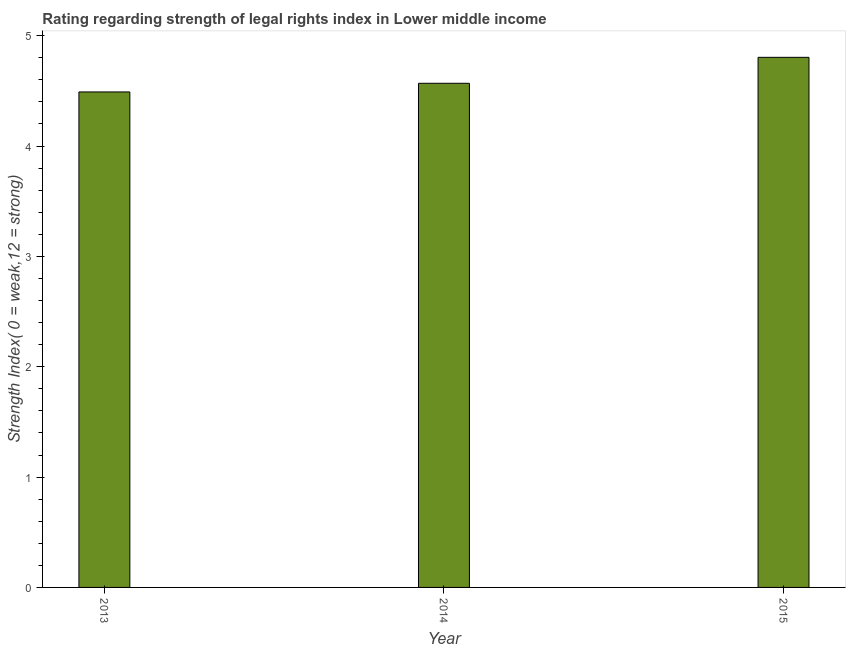Does the graph contain grids?
Make the answer very short. No. What is the title of the graph?
Offer a terse response. Rating regarding strength of legal rights index in Lower middle income. What is the label or title of the X-axis?
Offer a very short reply. Year. What is the label or title of the Y-axis?
Keep it short and to the point. Strength Index( 0 = weak,12 = strong). What is the strength of legal rights index in 2015?
Make the answer very short. 4.8. Across all years, what is the maximum strength of legal rights index?
Keep it short and to the point. 4.8. Across all years, what is the minimum strength of legal rights index?
Offer a terse response. 4.49. In which year was the strength of legal rights index maximum?
Make the answer very short. 2015. What is the sum of the strength of legal rights index?
Give a very brief answer. 13.86. What is the difference between the strength of legal rights index in 2014 and 2015?
Offer a terse response. -0.23. What is the average strength of legal rights index per year?
Provide a short and direct response. 4.62. What is the median strength of legal rights index?
Offer a very short reply. 4.57. In how many years, is the strength of legal rights index greater than 3.8 ?
Offer a terse response. 3. Do a majority of the years between 2014 and 2013 (inclusive) have strength of legal rights index greater than 3.6 ?
Your answer should be compact. No. What is the ratio of the strength of legal rights index in 2014 to that in 2015?
Your response must be concise. 0.95. What is the difference between the highest and the second highest strength of legal rights index?
Your response must be concise. 0.23. Is the sum of the strength of legal rights index in 2013 and 2014 greater than the maximum strength of legal rights index across all years?
Keep it short and to the point. Yes. What is the difference between the highest and the lowest strength of legal rights index?
Provide a succinct answer. 0.31. In how many years, is the strength of legal rights index greater than the average strength of legal rights index taken over all years?
Your answer should be very brief. 1. Are all the bars in the graph horizontal?
Your response must be concise. No. What is the difference between two consecutive major ticks on the Y-axis?
Provide a succinct answer. 1. What is the Strength Index( 0 = weak,12 = strong) of 2013?
Offer a terse response. 4.49. What is the Strength Index( 0 = weak,12 = strong) in 2014?
Give a very brief answer. 4.57. What is the Strength Index( 0 = weak,12 = strong) in 2015?
Give a very brief answer. 4.8. What is the difference between the Strength Index( 0 = weak,12 = strong) in 2013 and 2014?
Keep it short and to the point. -0.08. What is the difference between the Strength Index( 0 = weak,12 = strong) in 2013 and 2015?
Make the answer very short. -0.31. What is the difference between the Strength Index( 0 = weak,12 = strong) in 2014 and 2015?
Ensure brevity in your answer.  -0.24. What is the ratio of the Strength Index( 0 = weak,12 = strong) in 2013 to that in 2015?
Ensure brevity in your answer.  0.94. What is the ratio of the Strength Index( 0 = weak,12 = strong) in 2014 to that in 2015?
Make the answer very short. 0.95. 